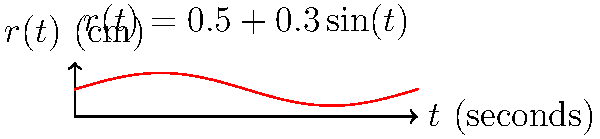As a vocal coach, you're analyzing a country singer's sustained note. The singer's vocal tract can be modeled as a cylinder with a time-varying radius $r(t) = 0.5 + 0.3\sin(t)$ cm, where $t$ is in seconds. The length of the vocal tract is constant at 17 cm. If the note is held for 4 seconds, calculate the total volume of air expelled during this time, assuming the air moves at a constant velocity of 340 cm/s through the tract. To solve this problem, we need to use integration to calculate the volume of air expelled over time. Let's break it down step-by-step:

1) The volume of air expelled at any instant is the cross-sectional area of the cylinder multiplied by the velocity:
   $V'(t) = \pi r(t)^2 \cdot 340$ cm³/s

2) Substituting $r(t) = 0.5 + 0.3\sin(t)$:
   $V'(t) = \pi (0.5 + 0.3\sin(t))^2 \cdot 340$ cm³/s

3) To find the total volume over 4 seconds, we integrate this function from 0 to 4:
   $V = \int_0^4 340\pi (0.5 + 0.3\sin(t))^2 dt$

4) Expanding the squared term:
   $V = 340\pi \int_0^4 (0.25 + 0.3\sin(t) + 0.09\sin^2(t)) dt$

5) Using the identity $\sin^2(t) = \frac{1-\cos(2t)}{2}$:
   $V = 340\pi \int_0^4 (0.25 + 0.3\sin(t) + 0.045 - 0.045\cos(2t)) dt$

6) Integrating each term:
   $V = 340\pi [0.295t - 0.3\cos(t) - 0.0225\sin(2t)]_0^4$

7) Evaluating the integral:
   $V = 340\pi [(0.295 \cdot 4 - 0.3\cos(4) - 0.0225\sin(8)) - (0 - 0.3 - 0)]$

8) Calculating the final result:
   $V \approx 1261.28$ cm³
Answer: 1261.28 cm³ 